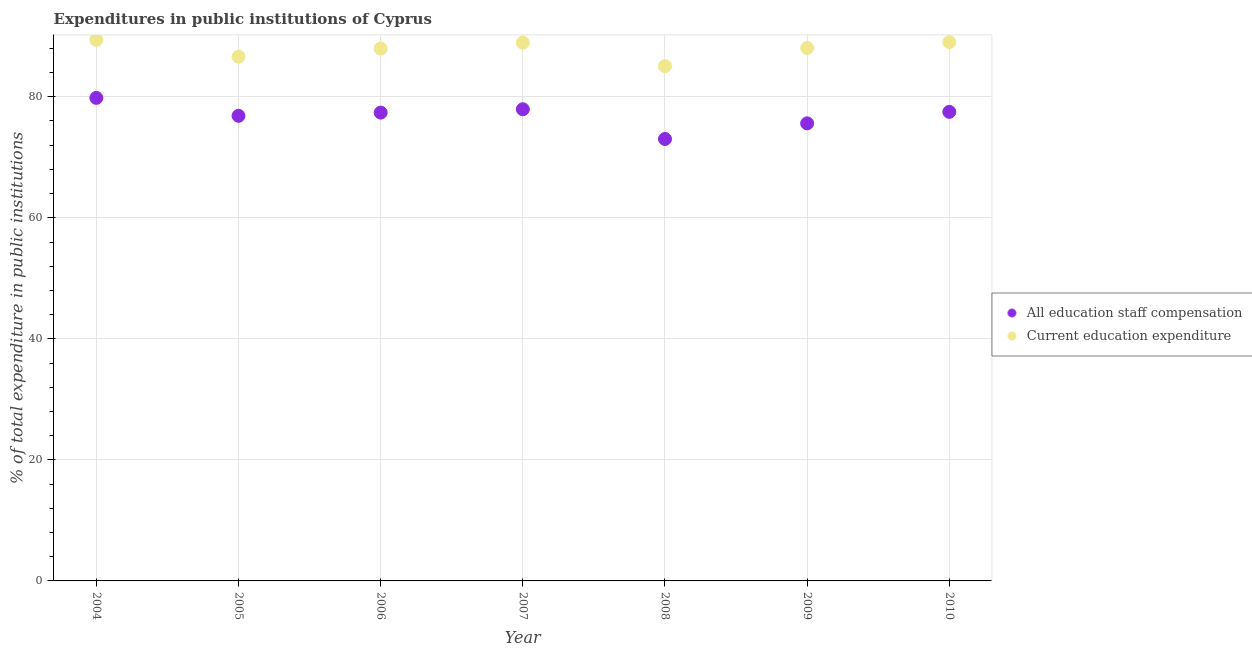What is the expenditure in education in 2006?
Keep it short and to the point. 87.97. Across all years, what is the maximum expenditure in education?
Ensure brevity in your answer.  89.41. Across all years, what is the minimum expenditure in education?
Offer a terse response. 85.07. What is the total expenditure in staff compensation in the graph?
Keep it short and to the point. 538.13. What is the difference between the expenditure in education in 2004 and that in 2005?
Your response must be concise. 2.79. What is the difference between the expenditure in staff compensation in 2010 and the expenditure in education in 2008?
Provide a short and direct response. -7.56. What is the average expenditure in education per year?
Ensure brevity in your answer.  87.87. In the year 2007, what is the difference between the expenditure in staff compensation and expenditure in education?
Your answer should be very brief. -11. In how many years, is the expenditure in staff compensation greater than 36 %?
Offer a very short reply. 7. What is the ratio of the expenditure in education in 2008 to that in 2010?
Offer a very short reply. 0.96. Is the expenditure in education in 2004 less than that in 2010?
Provide a succinct answer. No. Is the difference between the expenditure in staff compensation in 2005 and 2008 greater than the difference between the expenditure in education in 2005 and 2008?
Keep it short and to the point. Yes. What is the difference between the highest and the second highest expenditure in staff compensation?
Give a very brief answer. 1.88. What is the difference between the highest and the lowest expenditure in education?
Keep it short and to the point. 4.34. In how many years, is the expenditure in staff compensation greater than the average expenditure in staff compensation taken over all years?
Your answer should be compact. 4. Is the sum of the expenditure in staff compensation in 2008 and 2009 greater than the maximum expenditure in education across all years?
Offer a very short reply. Yes. Is the expenditure in staff compensation strictly less than the expenditure in education over the years?
Ensure brevity in your answer.  Yes. How many dotlines are there?
Ensure brevity in your answer.  2. Does the graph contain any zero values?
Your answer should be very brief. No. Where does the legend appear in the graph?
Your response must be concise. Center right. How many legend labels are there?
Your response must be concise. 2. How are the legend labels stacked?
Your answer should be very brief. Vertical. What is the title of the graph?
Your response must be concise. Expenditures in public institutions of Cyprus. Does "UN agencies" appear as one of the legend labels in the graph?
Provide a short and direct response. No. What is the label or title of the X-axis?
Offer a terse response. Year. What is the label or title of the Y-axis?
Keep it short and to the point. % of total expenditure in public institutions. What is the % of total expenditure in public institutions in All education staff compensation in 2004?
Provide a succinct answer. 79.82. What is the % of total expenditure in public institutions of Current education expenditure in 2004?
Your answer should be compact. 89.41. What is the % of total expenditure in public institutions in All education staff compensation in 2005?
Make the answer very short. 76.85. What is the % of total expenditure in public institutions in Current education expenditure in 2005?
Make the answer very short. 86.62. What is the % of total expenditure in public institutions in All education staff compensation in 2006?
Provide a short and direct response. 77.38. What is the % of total expenditure in public institutions of Current education expenditure in 2006?
Make the answer very short. 87.97. What is the % of total expenditure in public institutions of All education staff compensation in 2007?
Give a very brief answer. 77.94. What is the % of total expenditure in public institutions of Current education expenditure in 2007?
Ensure brevity in your answer.  88.94. What is the % of total expenditure in public institutions of All education staff compensation in 2008?
Ensure brevity in your answer.  73.03. What is the % of total expenditure in public institutions of Current education expenditure in 2008?
Provide a short and direct response. 85.07. What is the % of total expenditure in public institutions in All education staff compensation in 2009?
Keep it short and to the point. 75.61. What is the % of total expenditure in public institutions of Current education expenditure in 2009?
Offer a very short reply. 88.07. What is the % of total expenditure in public institutions in All education staff compensation in 2010?
Offer a very short reply. 77.51. What is the % of total expenditure in public institutions of Current education expenditure in 2010?
Keep it short and to the point. 89.04. Across all years, what is the maximum % of total expenditure in public institutions of All education staff compensation?
Give a very brief answer. 79.82. Across all years, what is the maximum % of total expenditure in public institutions of Current education expenditure?
Offer a terse response. 89.41. Across all years, what is the minimum % of total expenditure in public institutions in All education staff compensation?
Keep it short and to the point. 73.03. Across all years, what is the minimum % of total expenditure in public institutions of Current education expenditure?
Your answer should be very brief. 85.07. What is the total % of total expenditure in public institutions of All education staff compensation in the graph?
Make the answer very short. 538.13. What is the total % of total expenditure in public institutions in Current education expenditure in the graph?
Offer a very short reply. 615.12. What is the difference between the % of total expenditure in public institutions of All education staff compensation in 2004 and that in 2005?
Your answer should be compact. 2.97. What is the difference between the % of total expenditure in public institutions of Current education expenditure in 2004 and that in 2005?
Keep it short and to the point. 2.79. What is the difference between the % of total expenditure in public institutions of All education staff compensation in 2004 and that in 2006?
Provide a short and direct response. 2.44. What is the difference between the % of total expenditure in public institutions of Current education expenditure in 2004 and that in 2006?
Keep it short and to the point. 1.44. What is the difference between the % of total expenditure in public institutions in All education staff compensation in 2004 and that in 2007?
Give a very brief answer. 1.88. What is the difference between the % of total expenditure in public institutions in Current education expenditure in 2004 and that in 2007?
Your response must be concise. 0.47. What is the difference between the % of total expenditure in public institutions of All education staff compensation in 2004 and that in 2008?
Keep it short and to the point. 6.79. What is the difference between the % of total expenditure in public institutions in Current education expenditure in 2004 and that in 2008?
Offer a terse response. 4.34. What is the difference between the % of total expenditure in public institutions in All education staff compensation in 2004 and that in 2009?
Your answer should be very brief. 4.21. What is the difference between the % of total expenditure in public institutions of Current education expenditure in 2004 and that in 2009?
Ensure brevity in your answer.  1.34. What is the difference between the % of total expenditure in public institutions of All education staff compensation in 2004 and that in 2010?
Provide a succinct answer. 2.31. What is the difference between the % of total expenditure in public institutions in Current education expenditure in 2004 and that in 2010?
Offer a terse response. 0.37. What is the difference between the % of total expenditure in public institutions of All education staff compensation in 2005 and that in 2006?
Provide a short and direct response. -0.53. What is the difference between the % of total expenditure in public institutions in Current education expenditure in 2005 and that in 2006?
Give a very brief answer. -1.34. What is the difference between the % of total expenditure in public institutions in All education staff compensation in 2005 and that in 2007?
Ensure brevity in your answer.  -1.09. What is the difference between the % of total expenditure in public institutions of Current education expenditure in 2005 and that in 2007?
Provide a succinct answer. -2.32. What is the difference between the % of total expenditure in public institutions of All education staff compensation in 2005 and that in 2008?
Offer a very short reply. 3.83. What is the difference between the % of total expenditure in public institutions of Current education expenditure in 2005 and that in 2008?
Your response must be concise. 1.55. What is the difference between the % of total expenditure in public institutions in All education staff compensation in 2005 and that in 2009?
Ensure brevity in your answer.  1.24. What is the difference between the % of total expenditure in public institutions of Current education expenditure in 2005 and that in 2009?
Provide a short and direct response. -1.45. What is the difference between the % of total expenditure in public institutions of All education staff compensation in 2005 and that in 2010?
Give a very brief answer. -0.66. What is the difference between the % of total expenditure in public institutions in Current education expenditure in 2005 and that in 2010?
Provide a short and direct response. -2.41. What is the difference between the % of total expenditure in public institutions of All education staff compensation in 2006 and that in 2007?
Your answer should be compact. -0.56. What is the difference between the % of total expenditure in public institutions of Current education expenditure in 2006 and that in 2007?
Keep it short and to the point. -0.97. What is the difference between the % of total expenditure in public institutions of All education staff compensation in 2006 and that in 2008?
Keep it short and to the point. 4.36. What is the difference between the % of total expenditure in public institutions of Current education expenditure in 2006 and that in 2008?
Keep it short and to the point. 2.9. What is the difference between the % of total expenditure in public institutions of All education staff compensation in 2006 and that in 2009?
Make the answer very short. 1.77. What is the difference between the % of total expenditure in public institutions in Current education expenditure in 2006 and that in 2009?
Provide a succinct answer. -0.1. What is the difference between the % of total expenditure in public institutions in All education staff compensation in 2006 and that in 2010?
Give a very brief answer. -0.12. What is the difference between the % of total expenditure in public institutions in Current education expenditure in 2006 and that in 2010?
Give a very brief answer. -1.07. What is the difference between the % of total expenditure in public institutions in All education staff compensation in 2007 and that in 2008?
Your response must be concise. 4.91. What is the difference between the % of total expenditure in public institutions in Current education expenditure in 2007 and that in 2008?
Your answer should be compact. 3.87. What is the difference between the % of total expenditure in public institutions of All education staff compensation in 2007 and that in 2009?
Offer a terse response. 2.33. What is the difference between the % of total expenditure in public institutions in Current education expenditure in 2007 and that in 2009?
Your answer should be compact. 0.87. What is the difference between the % of total expenditure in public institutions of All education staff compensation in 2007 and that in 2010?
Offer a very short reply. 0.43. What is the difference between the % of total expenditure in public institutions of Current education expenditure in 2007 and that in 2010?
Give a very brief answer. -0.1. What is the difference between the % of total expenditure in public institutions in All education staff compensation in 2008 and that in 2009?
Your answer should be very brief. -2.58. What is the difference between the % of total expenditure in public institutions in Current education expenditure in 2008 and that in 2009?
Offer a very short reply. -3. What is the difference between the % of total expenditure in public institutions of All education staff compensation in 2008 and that in 2010?
Provide a succinct answer. -4.48. What is the difference between the % of total expenditure in public institutions of Current education expenditure in 2008 and that in 2010?
Your answer should be very brief. -3.97. What is the difference between the % of total expenditure in public institutions in All education staff compensation in 2009 and that in 2010?
Provide a succinct answer. -1.9. What is the difference between the % of total expenditure in public institutions of Current education expenditure in 2009 and that in 2010?
Your answer should be very brief. -0.97. What is the difference between the % of total expenditure in public institutions in All education staff compensation in 2004 and the % of total expenditure in public institutions in Current education expenditure in 2005?
Provide a succinct answer. -6.81. What is the difference between the % of total expenditure in public institutions in All education staff compensation in 2004 and the % of total expenditure in public institutions in Current education expenditure in 2006?
Give a very brief answer. -8.15. What is the difference between the % of total expenditure in public institutions in All education staff compensation in 2004 and the % of total expenditure in public institutions in Current education expenditure in 2007?
Your response must be concise. -9.12. What is the difference between the % of total expenditure in public institutions in All education staff compensation in 2004 and the % of total expenditure in public institutions in Current education expenditure in 2008?
Your answer should be compact. -5.25. What is the difference between the % of total expenditure in public institutions in All education staff compensation in 2004 and the % of total expenditure in public institutions in Current education expenditure in 2009?
Keep it short and to the point. -8.25. What is the difference between the % of total expenditure in public institutions of All education staff compensation in 2004 and the % of total expenditure in public institutions of Current education expenditure in 2010?
Give a very brief answer. -9.22. What is the difference between the % of total expenditure in public institutions of All education staff compensation in 2005 and the % of total expenditure in public institutions of Current education expenditure in 2006?
Provide a short and direct response. -11.12. What is the difference between the % of total expenditure in public institutions of All education staff compensation in 2005 and the % of total expenditure in public institutions of Current education expenditure in 2007?
Your answer should be compact. -12.09. What is the difference between the % of total expenditure in public institutions in All education staff compensation in 2005 and the % of total expenditure in public institutions in Current education expenditure in 2008?
Your response must be concise. -8.22. What is the difference between the % of total expenditure in public institutions of All education staff compensation in 2005 and the % of total expenditure in public institutions of Current education expenditure in 2009?
Give a very brief answer. -11.22. What is the difference between the % of total expenditure in public institutions of All education staff compensation in 2005 and the % of total expenditure in public institutions of Current education expenditure in 2010?
Your answer should be very brief. -12.19. What is the difference between the % of total expenditure in public institutions of All education staff compensation in 2006 and the % of total expenditure in public institutions of Current education expenditure in 2007?
Make the answer very short. -11.56. What is the difference between the % of total expenditure in public institutions in All education staff compensation in 2006 and the % of total expenditure in public institutions in Current education expenditure in 2008?
Your response must be concise. -7.69. What is the difference between the % of total expenditure in public institutions of All education staff compensation in 2006 and the % of total expenditure in public institutions of Current education expenditure in 2009?
Make the answer very short. -10.69. What is the difference between the % of total expenditure in public institutions of All education staff compensation in 2006 and the % of total expenditure in public institutions of Current education expenditure in 2010?
Ensure brevity in your answer.  -11.65. What is the difference between the % of total expenditure in public institutions of All education staff compensation in 2007 and the % of total expenditure in public institutions of Current education expenditure in 2008?
Make the answer very short. -7.13. What is the difference between the % of total expenditure in public institutions in All education staff compensation in 2007 and the % of total expenditure in public institutions in Current education expenditure in 2009?
Provide a succinct answer. -10.13. What is the difference between the % of total expenditure in public institutions in All education staff compensation in 2007 and the % of total expenditure in public institutions in Current education expenditure in 2010?
Provide a short and direct response. -11.1. What is the difference between the % of total expenditure in public institutions of All education staff compensation in 2008 and the % of total expenditure in public institutions of Current education expenditure in 2009?
Keep it short and to the point. -15.04. What is the difference between the % of total expenditure in public institutions of All education staff compensation in 2008 and the % of total expenditure in public institutions of Current education expenditure in 2010?
Your response must be concise. -16.01. What is the difference between the % of total expenditure in public institutions in All education staff compensation in 2009 and the % of total expenditure in public institutions in Current education expenditure in 2010?
Make the answer very short. -13.43. What is the average % of total expenditure in public institutions of All education staff compensation per year?
Your answer should be compact. 76.88. What is the average % of total expenditure in public institutions of Current education expenditure per year?
Make the answer very short. 87.87. In the year 2004, what is the difference between the % of total expenditure in public institutions of All education staff compensation and % of total expenditure in public institutions of Current education expenditure?
Keep it short and to the point. -9.59. In the year 2005, what is the difference between the % of total expenditure in public institutions of All education staff compensation and % of total expenditure in public institutions of Current education expenditure?
Provide a short and direct response. -9.77. In the year 2006, what is the difference between the % of total expenditure in public institutions in All education staff compensation and % of total expenditure in public institutions in Current education expenditure?
Provide a succinct answer. -10.59. In the year 2007, what is the difference between the % of total expenditure in public institutions in All education staff compensation and % of total expenditure in public institutions in Current education expenditure?
Keep it short and to the point. -11. In the year 2008, what is the difference between the % of total expenditure in public institutions in All education staff compensation and % of total expenditure in public institutions in Current education expenditure?
Provide a short and direct response. -12.04. In the year 2009, what is the difference between the % of total expenditure in public institutions in All education staff compensation and % of total expenditure in public institutions in Current education expenditure?
Ensure brevity in your answer.  -12.46. In the year 2010, what is the difference between the % of total expenditure in public institutions in All education staff compensation and % of total expenditure in public institutions in Current education expenditure?
Your answer should be compact. -11.53. What is the ratio of the % of total expenditure in public institutions of All education staff compensation in 2004 to that in 2005?
Your answer should be very brief. 1.04. What is the ratio of the % of total expenditure in public institutions in Current education expenditure in 2004 to that in 2005?
Provide a short and direct response. 1.03. What is the ratio of the % of total expenditure in public institutions of All education staff compensation in 2004 to that in 2006?
Your answer should be very brief. 1.03. What is the ratio of the % of total expenditure in public institutions in Current education expenditure in 2004 to that in 2006?
Offer a terse response. 1.02. What is the ratio of the % of total expenditure in public institutions in All education staff compensation in 2004 to that in 2007?
Provide a short and direct response. 1.02. What is the ratio of the % of total expenditure in public institutions in Current education expenditure in 2004 to that in 2007?
Provide a succinct answer. 1.01. What is the ratio of the % of total expenditure in public institutions in All education staff compensation in 2004 to that in 2008?
Make the answer very short. 1.09. What is the ratio of the % of total expenditure in public institutions in Current education expenditure in 2004 to that in 2008?
Your response must be concise. 1.05. What is the ratio of the % of total expenditure in public institutions of All education staff compensation in 2004 to that in 2009?
Provide a succinct answer. 1.06. What is the ratio of the % of total expenditure in public institutions of Current education expenditure in 2004 to that in 2009?
Your response must be concise. 1.02. What is the ratio of the % of total expenditure in public institutions of All education staff compensation in 2004 to that in 2010?
Ensure brevity in your answer.  1.03. What is the ratio of the % of total expenditure in public institutions in All education staff compensation in 2005 to that in 2006?
Ensure brevity in your answer.  0.99. What is the ratio of the % of total expenditure in public institutions of Current education expenditure in 2005 to that in 2006?
Provide a succinct answer. 0.98. What is the ratio of the % of total expenditure in public institutions of Current education expenditure in 2005 to that in 2007?
Provide a succinct answer. 0.97. What is the ratio of the % of total expenditure in public institutions in All education staff compensation in 2005 to that in 2008?
Provide a short and direct response. 1.05. What is the ratio of the % of total expenditure in public institutions in Current education expenditure in 2005 to that in 2008?
Provide a succinct answer. 1.02. What is the ratio of the % of total expenditure in public institutions of All education staff compensation in 2005 to that in 2009?
Ensure brevity in your answer.  1.02. What is the ratio of the % of total expenditure in public institutions of Current education expenditure in 2005 to that in 2009?
Offer a terse response. 0.98. What is the ratio of the % of total expenditure in public institutions in Current education expenditure in 2005 to that in 2010?
Provide a short and direct response. 0.97. What is the ratio of the % of total expenditure in public institutions of Current education expenditure in 2006 to that in 2007?
Provide a succinct answer. 0.99. What is the ratio of the % of total expenditure in public institutions in All education staff compensation in 2006 to that in 2008?
Make the answer very short. 1.06. What is the ratio of the % of total expenditure in public institutions of Current education expenditure in 2006 to that in 2008?
Provide a short and direct response. 1.03. What is the ratio of the % of total expenditure in public institutions of All education staff compensation in 2006 to that in 2009?
Your answer should be very brief. 1.02. What is the ratio of the % of total expenditure in public institutions of Current education expenditure in 2006 to that in 2009?
Provide a short and direct response. 1. What is the ratio of the % of total expenditure in public institutions of Current education expenditure in 2006 to that in 2010?
Offer a very short reply. 0.99. What is the ratio of the % of total expenditure in public institutions of All education staff compensation in 2007 to that in 2008?
Your answer should be compact. 1.07. What is the ratio of the % of total expenditure in public institutions of Current education expenditure in 2007 to that in 2008?
Your answer should be very brief. 1.05. What is the ratio of the % of total expenditure in public institutions of All education staff compensation in 2007 to that in 2009?
Give a very brief answer. 1.03. What is the ratio of the % of total expenditure in public institutions of Current education expenditure in 2007 to that in 2009?
Offer a very short reply. 1.01. What is the ratio of the % of total expenditure in public institutions in All education staff compensation in 2007 to that in 2010?
Your response must be concise. 1.01. What is the ratio of the % of total expenditure in public institutions in All education staff compensation in 2008 to that in 2009?
Your response must be concise. 0.97. What is the ratio of the % of total expenditure in public institutions in Current education expenditure in 2008 to that in 2009?
Give a very brief answer. 0.97. What is the ratio of the % of total expenditure in public institutions of All education staff compensation in 2008 to that in 2010?
Your response must be concise. 0.94. What is the ratio of the % of total expenditure in public institutions in Current education expenditure in 2008 to that in 2010?
Offer a very short reply. 0.96. What is the ratio of the % of total expenditure in public institutions of All education staff compensation in 2009 to that in 2010?
Provide a succinct answer. 0.98. What is the difference between the highest and the second highest % of total expenditure in public institutions in All education staff compensation?
Your response must be concise. 1.88. What is the difference between the highest and the second highest % of total expenditure in public institutions of Current education expenditure?
Your answer should be very brief. 0.37. What is the difference between the highest and the lowest % of total expenditure in public institutions of All education staff compensation?
Provide a short and direct response. 6.79. What is the difference between the highest and the lowest % of total expenditure in public institutions of Current education expenditure?
Offer a terse response. 4.34. 